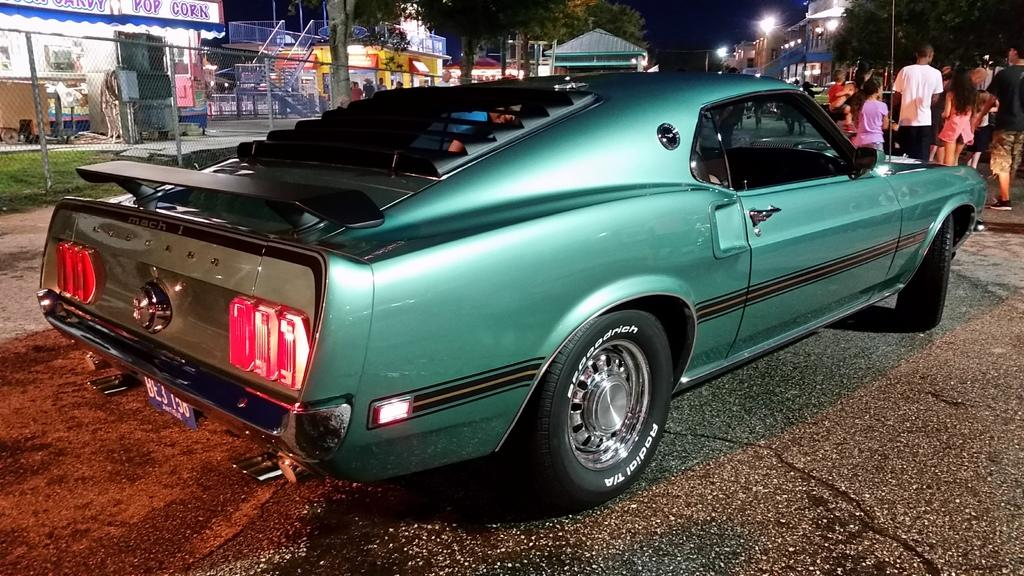What is the main subject in the center of the image? There is a car in the center of the image. Where is the car located? The car is on the road. What can be seen in the background of the image? In the background of the image, there are people, lights, trees, poles, stairs, boards, and a fence. What is the opinion of the basketball on the relation between the car and the fence? There is no basketball present in the image, and therefore it cannot have an opinion on the relation between the car and the fence. 